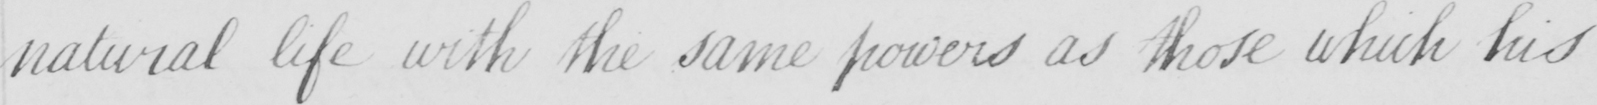What does this handwritten line say? natural life with the same powers as those which his 